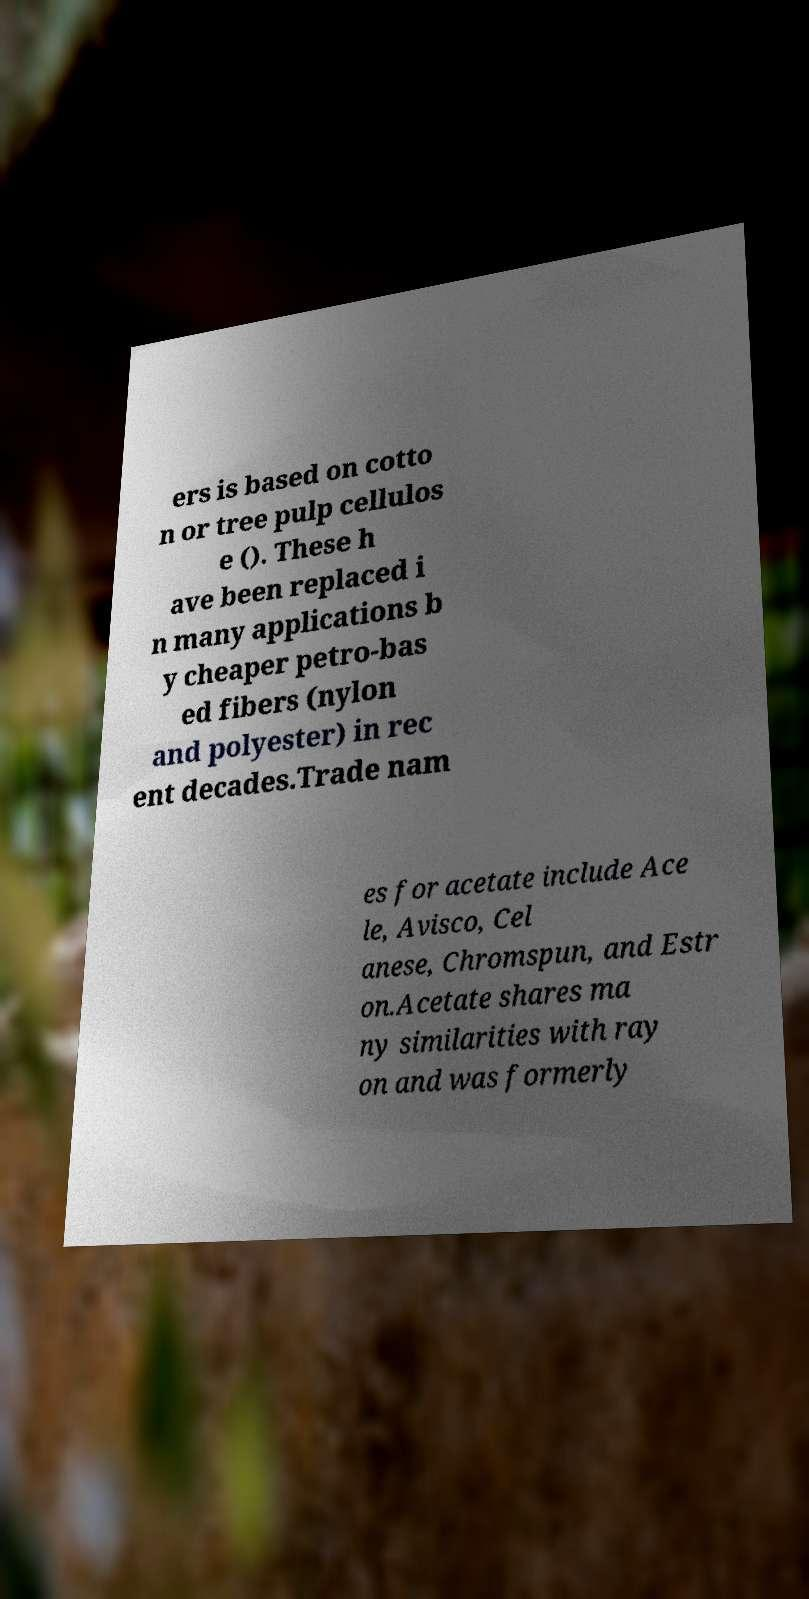I need the written content from this picture converted into text. Can you do that? ers is based on cotto n or tree pulp cellulos e (). These h ave been replaced i n many applications b y cheaper petro-bas ed fibers (nylon and polyester) in rec ent decades.Trade nam es for acetate include Ace le, Avisco, Cel anese, Chromspun, and Estr on.Acetate shares ma ny similarities with ray on and was formerly 